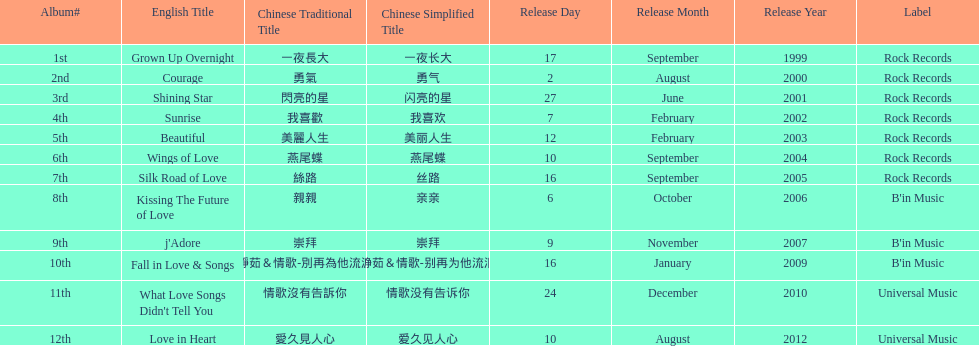What label was she working with before universal music? B'in Music. 